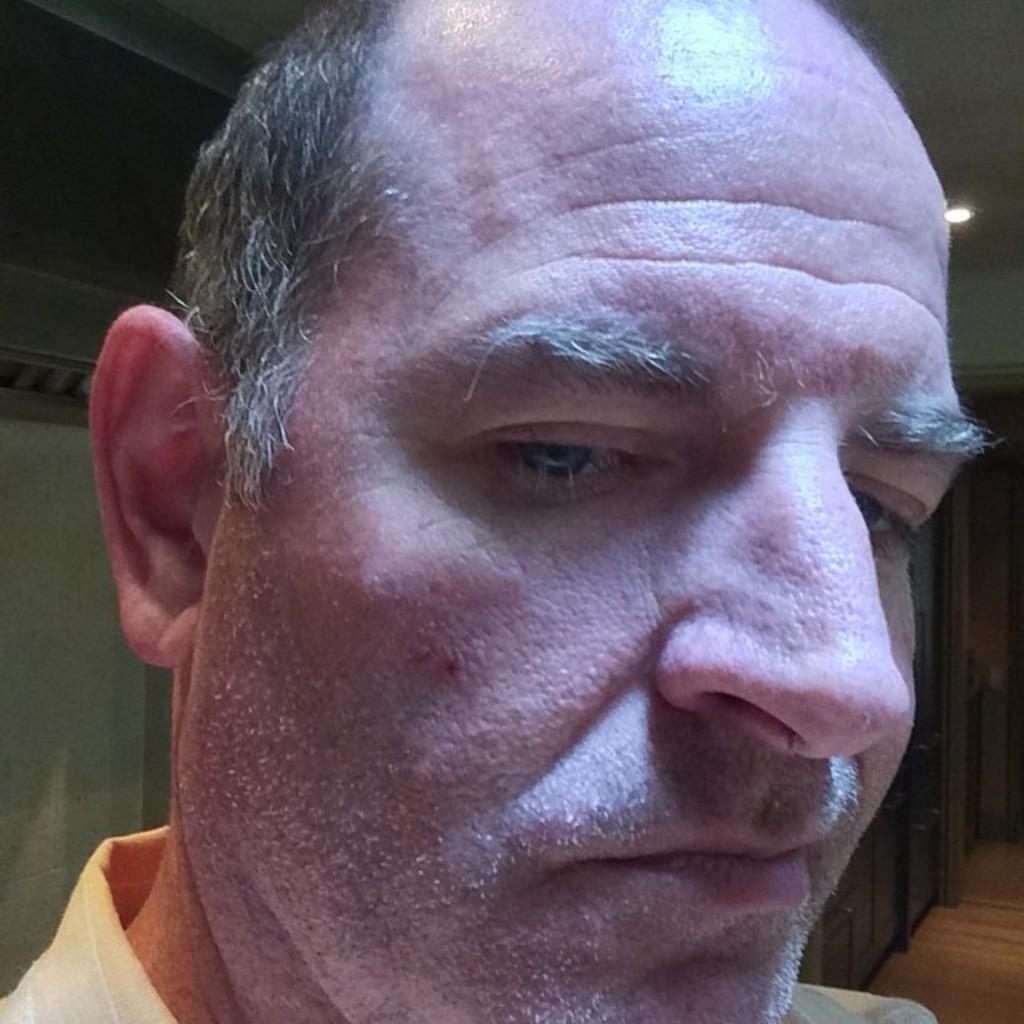Can you describe this image briefly? This image is taken indoors. In the background there is a wall. At the top of the image there is a ceiling with a light. On the right side of the image there is a floor. In the middle of the image there is a man. 